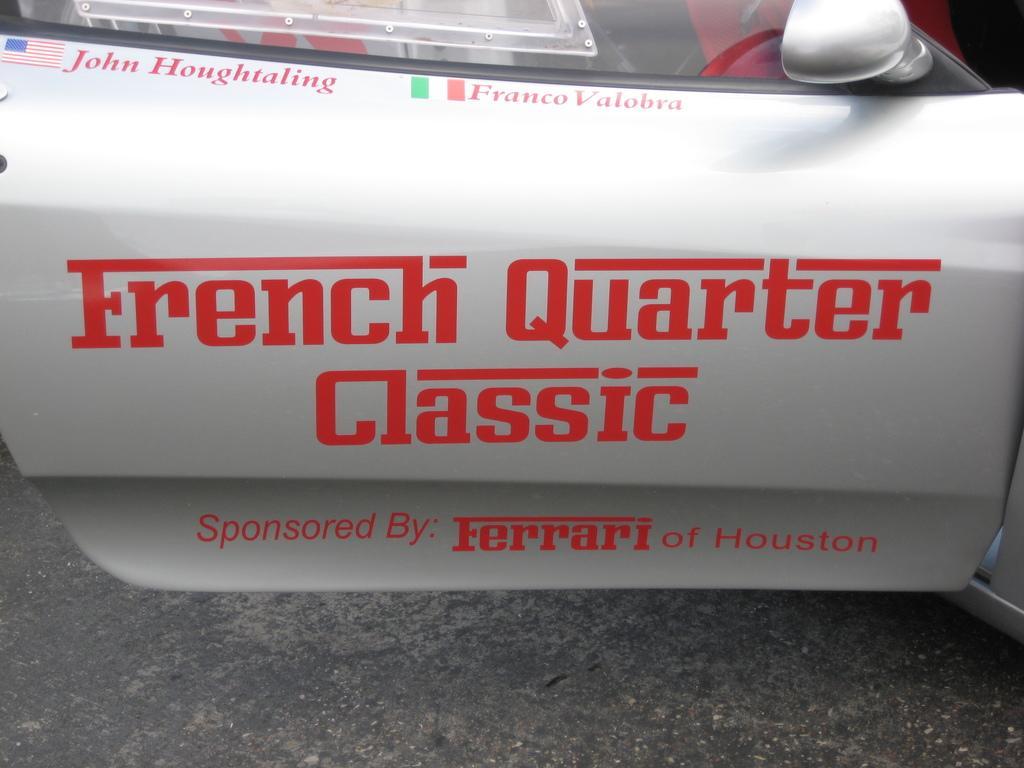Describe this image in one or two sentences. In this picture we observe a car door on which French Quarter Classic Sponsored by Ferrari by Houston. 